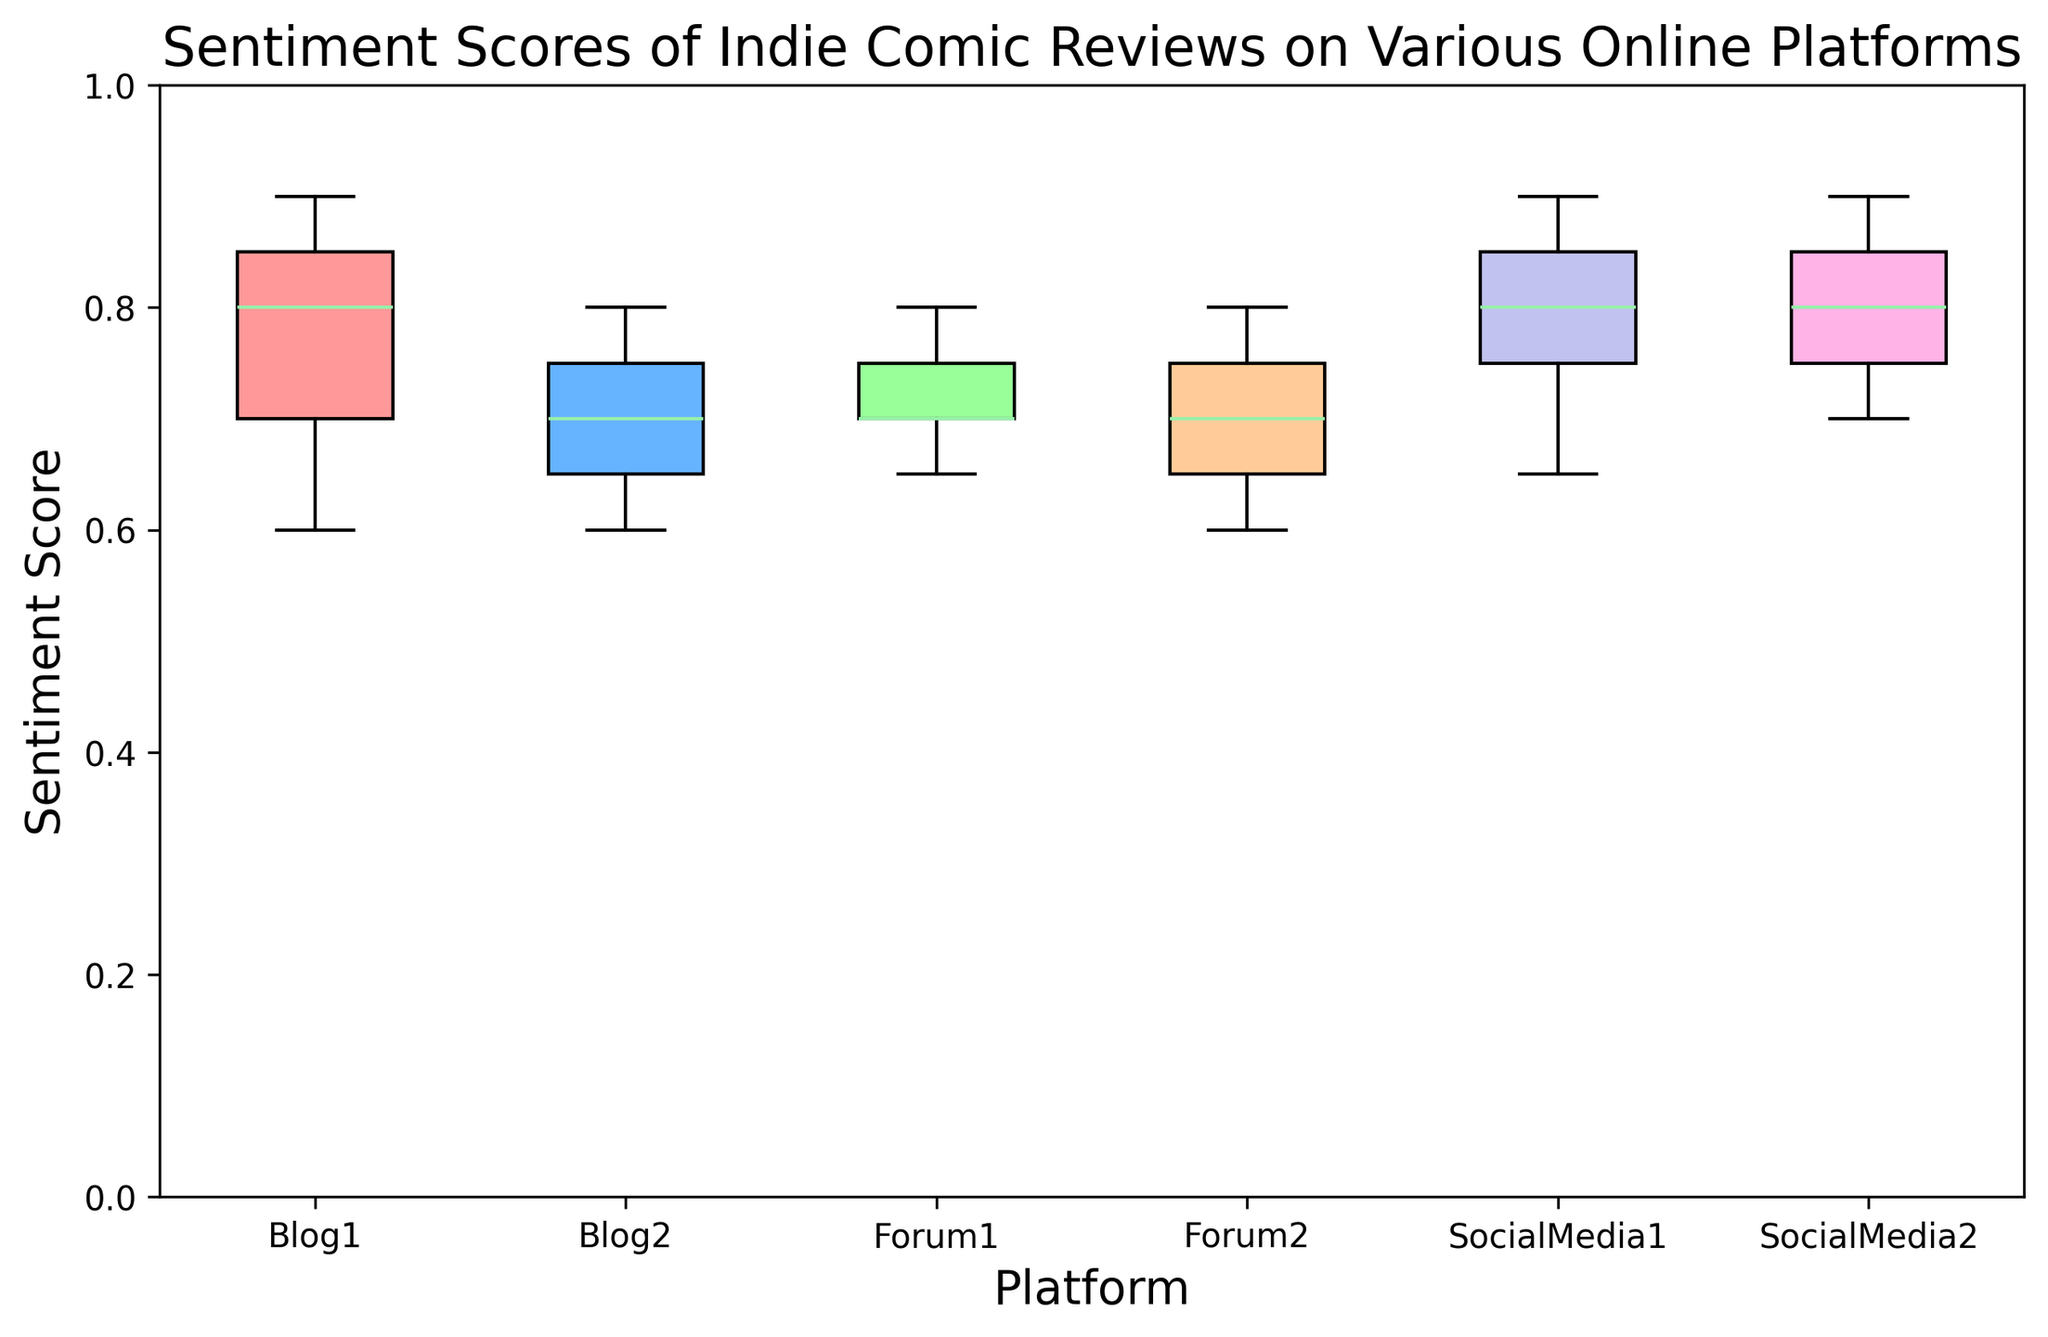What is the median sentiment score for reviews on Blog1? To find the median, look at the box plot for Blog1 and identify the middle value of the sentiment scores.
Answer: 0.8 Which platform has the highest median sentiment score? Check the median line in each box plot and identify the highest one.
Answer: SocialMedia2 How does the interquartile range (IQR) of Forum2 compare to that of Blog2? The IQR is the range between the first and third quartile. Compare the length of the boxes for Forum2 and Blog2.
Answer: Forum2 has a larger IQR Which platform has the lowest maximum sentiment score, and what is that score? Locate the highest point of each whisker and find the lowest among them.
Answer: Blog2, 0.8 What is the range of sentiment scores for SocialMedia1? The range is the difference between the maximum and minimum values.
Answer: 0.9 - 0.65 = 0.25 Between Forum1 and Forum2, which has a higher third quartile (75th percentile)? Locate the top edge of the box for both Forum1 and Forum2 and compare.
Answer: Forum2 Which platform has the most consistent (least variable) sentiment scores based on the box plots? The most consistent set of scores will have the shortest box and whiskers.
Answer: SocialMedia2 What is the difference between the median sentiment scores of Blog1 and Forum1? Subtract the median sentiment score of Forum1 from that of Blog1.
Answer: 0.8 - 0.7 = 0.1 How many platforms have a median sentiment score above 0.75? Count the platforms where the median line in the box plot is above 0.75.
Answer: 3 Which platform seems to have the widest range of sentiment scores visually? The platform with the longest whiskers or box indicates a wider range.
Answer: Blog2 